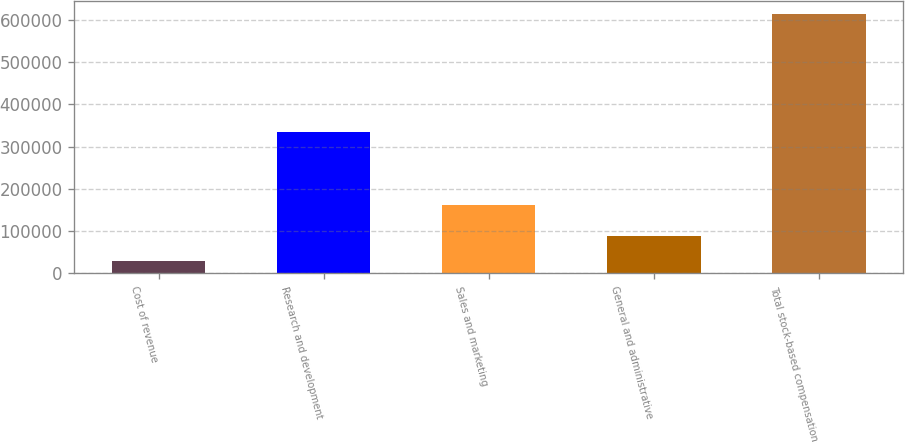Convert chart. <chart><loc_0><loc_0><loc_500><loc_500><bar_chart><fcel>Cost of revenue<fcel>Research and development<fcel>Sales and marketing<fcel>General and administrative<fcel>Total stock-based compensation<nl><fcel>29502<fcel>335498<fcel>160935<fcel>89298<fcel>615233<nl></chart> 